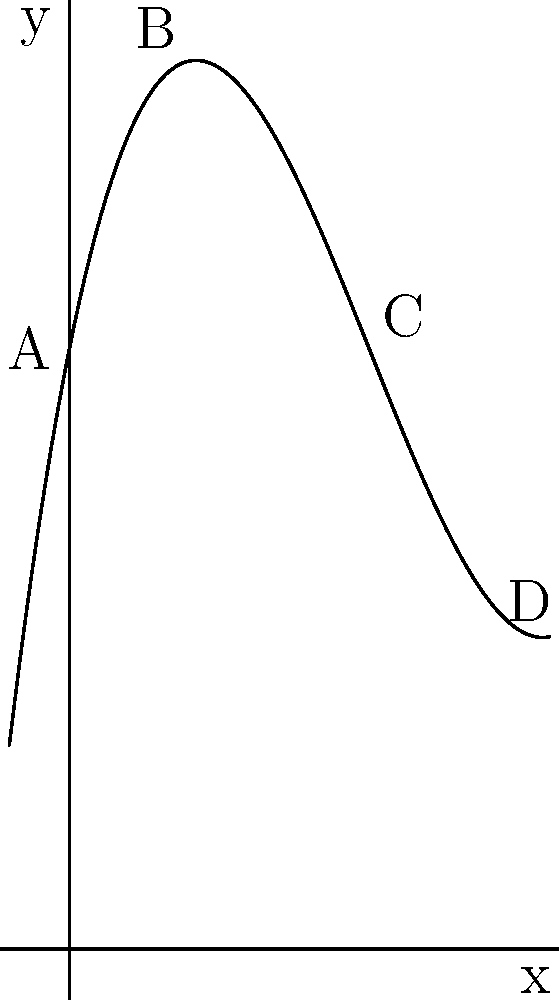As a horror film actress specializing in monstrous transformations, you're analyzing a polynomial function representing the growth rate of tentacle-like appendages for a new character design. The function is given by $f(x) = 0.1x^3 - 1.5x^2 + 5x + 10$, where $x$ represents time in hours and $f(x)$ represents the length of the appendages in centimeters. Based on the graph, at which point does the growth rate of the appendages start to accelerate rapidly? To determine where the growth rate starts to accelerate rapidly, we need to analyze the graph's behavior:

1. The graph represents the polynomial function $f(x) = 0.1x^3 - 1.5x^2 + 5x + 10$.
2. We're looking for a point where the curve's steepness increases significantly.
3. Observing the graph from left to right:
   - At point A (0,10), the curve starts with a moderate upward slope.
   - At point B (approximately at x=2), the curve's slope decreases, forming a slight dip.
   - Between points B and C, the curve's slope starts to increase again.
   - At point C (approximately at x=5), we can see that the curve begins to rise much more steeply.
   - After point C, towards point D, the curve's steepness continues to increase rapidly.
4. The rapid acceleration in growth rate is most evident starting from point C.

Therefore, the growth rate of the appendages starts to accelerate rapidly at point C, which corresponds to approximately 5 hours after the transformation begins.
Answer: Point C (approximately 5 hours) 